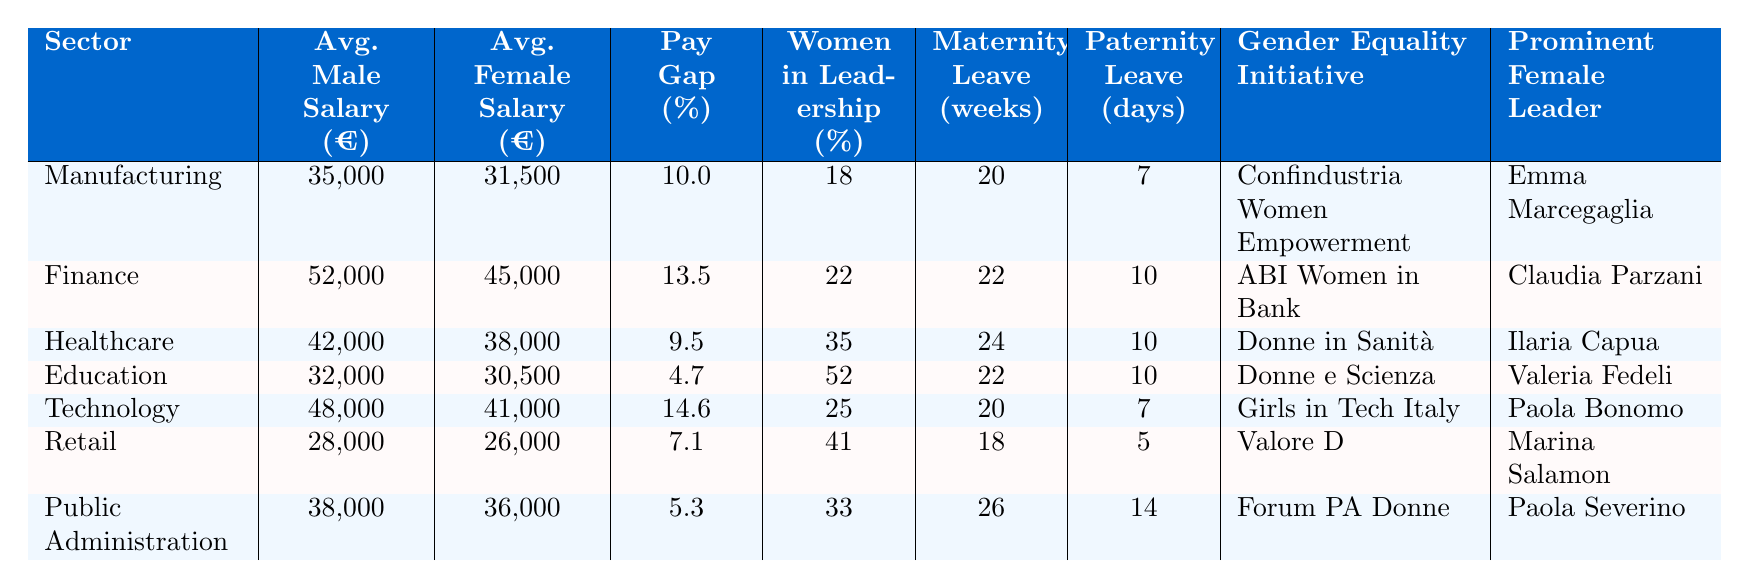What is the average male salary in the Finance sector? The table indicates that the average male salary in the Finance sector is €52,000.
Answer: €52,000 Which sector has the highest gender pay gap percentage? By looking at the gender pay gap percentages, Technology has the highest figure at 14.6%.
Answer: Technology In which sector do women hold the most leadership positions? The Education sector has the highest percentage of women in leadership positions at 52%.
Answer: Education What is the average female salary in the Retail sector? According to the table, the average female salary in the Retail sector is €26,000.
Answer: €26,000 Is the gender pay gap in Healthcare greater than in Public Administration? The gender pay gap in Healthcare is 9.5%, while in Public Administration it is only 5.3%, so yes, Healthcare has a greater pay gap.
Answer: Yes What is the maternity leave duration in the Manufacturing sector? The table shows that the maternity leave duration in the Manufacturing sector is 20 weeks.
Answer: 20 weeks Calculate the average salary for men across all sectors. The average male salary can be calculated by summing the male salaries (€35,000 + €52,000 + €42,000 + €32,000 + €48,000 + €28,000 + €38,000) = €275,000. There are 7 sectors, so the average is €275,000 / 7 ≈ €39,286.
Answer: €39,286 How many more weeks of maternity leave do women receive in Public Administration compared to Retail? The maternity leave in Public Administration is 26 weeks and in Retail, it is 18 weeks. The difference is 26 - 18 = 8 weeks.
Answer: 8 weeks What percentage of women are in leadership positions in the Technology sector? The Technology sector has 25% of women in leadership positions according to the table.
Answer: 25% Is the prominent female leader in Healthcare also associated with a gender equality initiative? Yes, Ilaria Capua, a prominent female leader in Healthcare, is associated with the gender equality initiative "Donne in Sanità."
Answer: Yes Which sector offers the least average female salary and what is it? The least average female salary is found in the Retail sector, where it is €26,000.
Answer: €26,000 